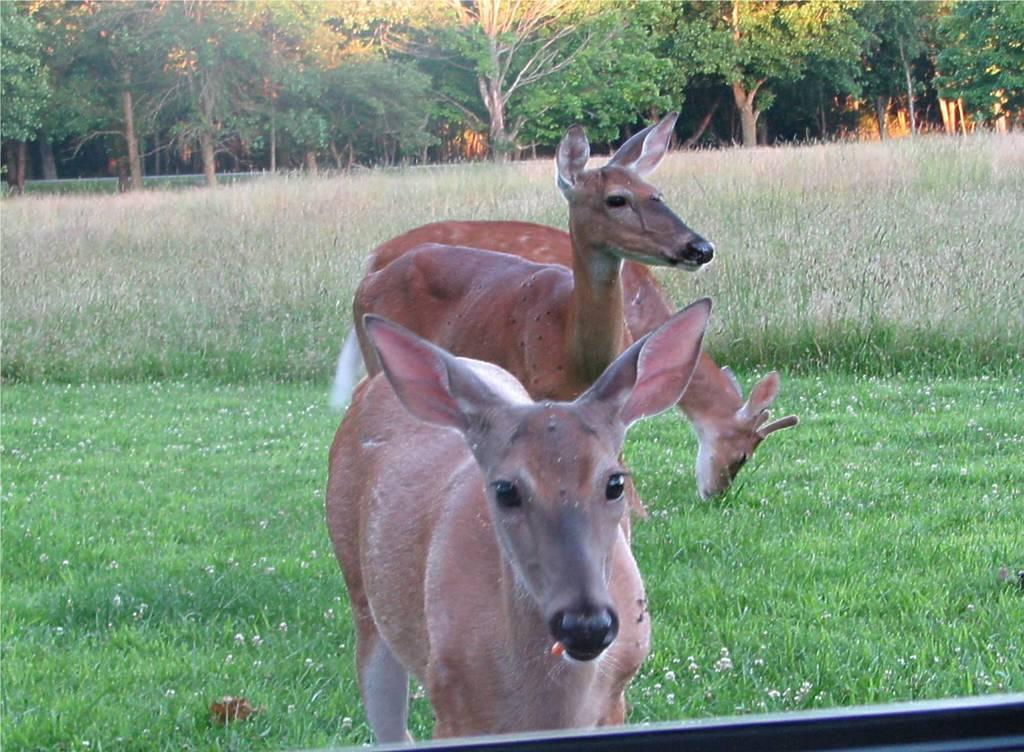What is the main subject of the image? There are three dresses standing in the image. What type of natural environment is visible in the image? There is grass visible in the image. What can be seen in the background of the image? There are trees in the background of the image. What features do the trees have? The trees have branches and leaves. What type of cord is being used to tie the dresses together in the image? There is no cord visible in the image, and the dresses are not tied together. What kind of breakfast is being served on the grass in the image? There is no breakfast or any food visible in the image; it only features three dresses and trees in the background. 